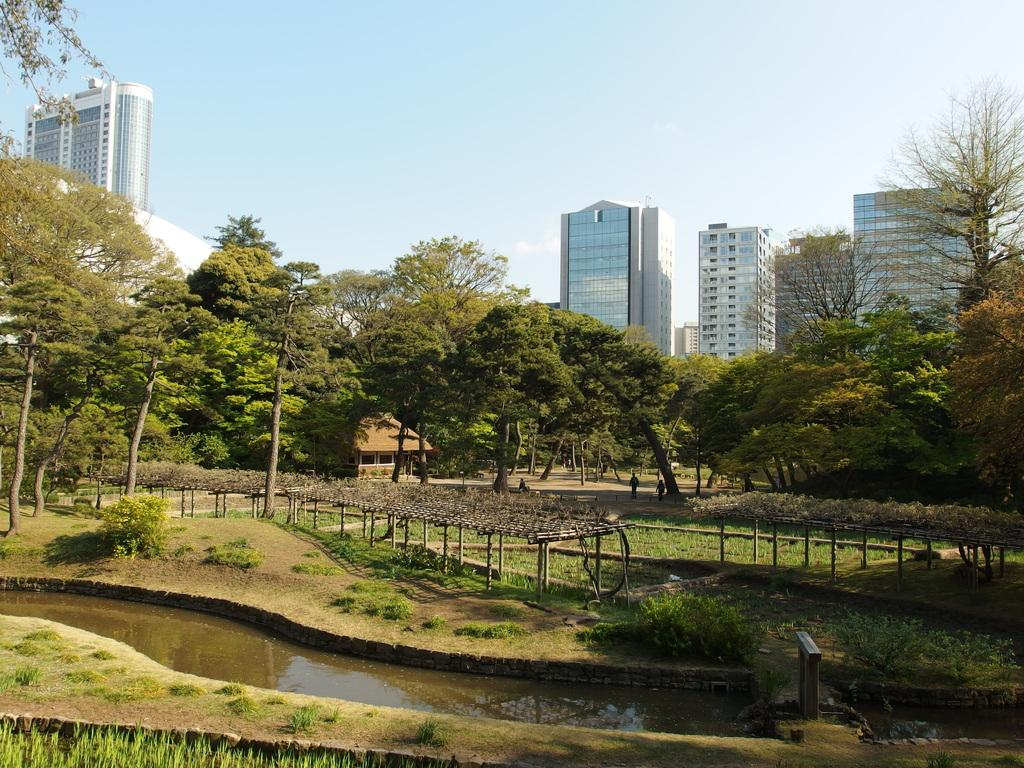What type of vegetation can be seen in the image? There are trees, plants, and grass visible in the image. What natural element is present in the image? Water is visible in the image. What can be seen in the background of the image? There are buildings and the sky visible in the background of the image. What type of pancake is being used to support the buildings in the image? There is no pancake present in the image, and the buildings are not being supported by any pancake. 